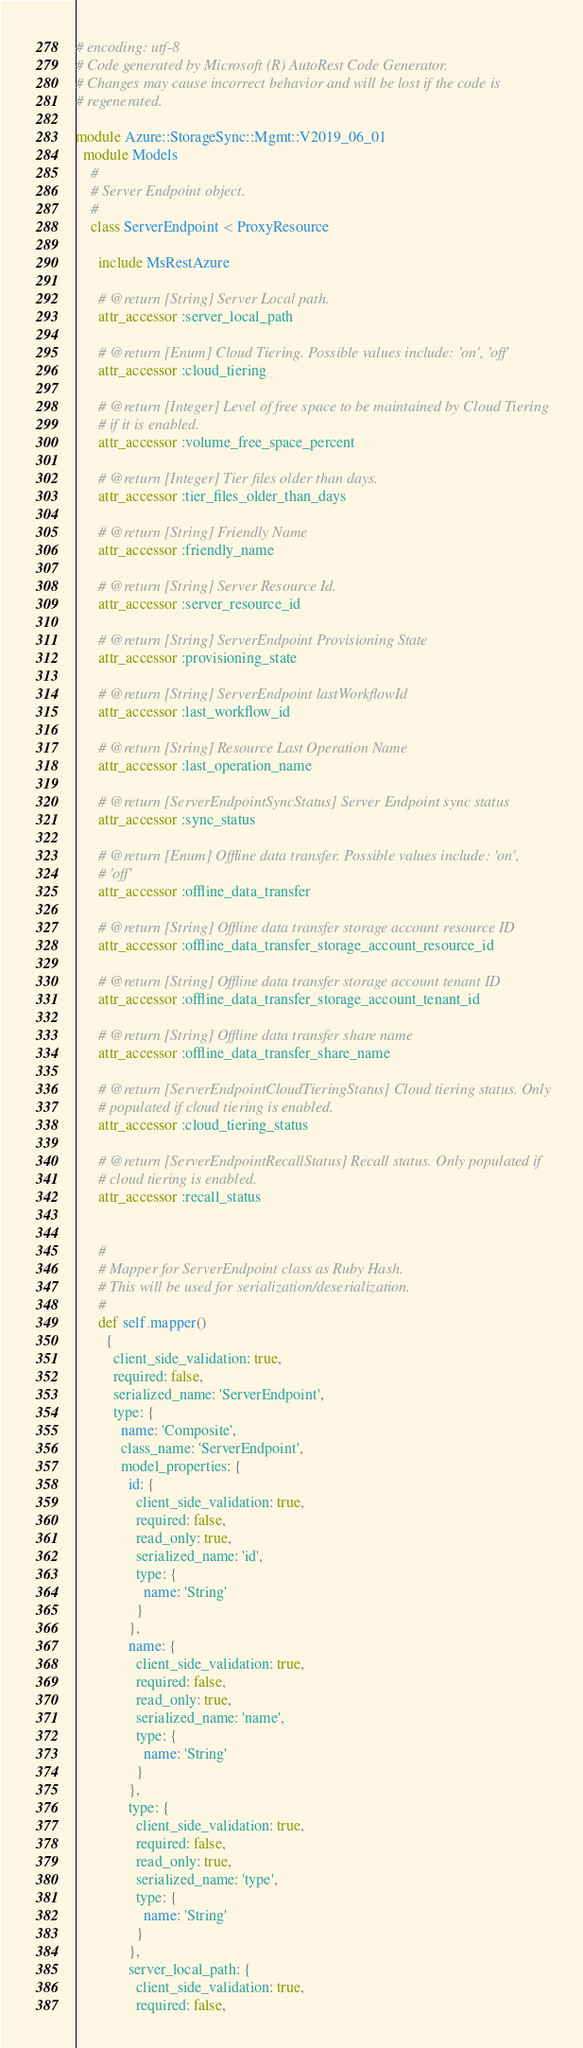Convert code to text. <code><loc_0><loc_0><loc_500><loc_500><_Ruby_># encoding: utf-8
# Code generated by Microsoft (R) AutoRest Code Generator.
# Changes may cause incorrect behavior and will be lost if the code is
# regenerated.

module Azure::StorageSync::Mgmt::V2019_06_01
  module Models
    #
    # Server Endpoint object.
    #
    class ServerEndpoint < ProxyResource

      include MsRestAzure

      # @return [String] Server Local path.
      attr_accessor :server_local_path

      # @return [Enum] Cloud Tiering. Possible values include: 'on', 'off'
      attr_accessor :cloud_tiering

      # @return [Integer] Level of free space to be maintained by Cloud Tiering
      # if it is enabled.
      attr_accessor :volume_free_space_percent

      # @return [Integer] Tier files older than days.
      attr_accessor :tier_files_older_than_days

      # @return [String] Friendly Name
      attr_accessor :friendly_name

      # @return [String] Server Resource Id.
      attr_accessor :server_resource_id

      # @return [String] ServerEndpoint Provisioning State
      attr_accessor :provisioning_state

      # @return [String] ServerEndpoint lastWorkflowId
      attr_accessor :last_workflow_id

      # @return [String] Resource Last Operation Name
      attr_accessor :last_operation_name

      # @return [ServerEndpointSyncStatus] Server Endpoint sync status
      attr_accessor :sync_status

      # @return [Enum] Offline data transfer. Possible values include: 'on',
      # 'off'
      attr_accessor :offline_data_transfer

      # @return [String] Offline data transfer storage account resource ID
      attr_accessor :offline_data_transfer_storage_account_resource_id

      # @return [String] Offline data transfer storage account tenant ID
      attr_accessor :offline_data_transfer_storage_account_tenant_id

      # @return [String] Offline data transfer share name
      attr_accessor :offline_data_transfer_share_name

      # @return [ServerEndpointCloudTieringStatus] Cloud tiering status. Only
      # populated if cloud tiering is enabled.
      attr_accessor :cloud_tiering_status

      # @return [ServerEndpointRecallStatus] Recall status. Only populated if
      # cloud tiering is enabled.
      attr_accessor :recall_status


      #
      # Mapper for ServerEndpoint class as Ruby Hash.
      # This will be used for serialization/deserialization.
      #
      def self.mapper()
        {
          client_side_validation: true,
          required: false,
          serialized_name: 'ServerEndpoint',
          type: {
            name: 'Composite',
            class_name: 'ServerEndpoint',
            model_properties: {
              id: {
                client_side_validation: true,
                required: false,
                read_only: true,
                serialized_name: 'id',
                type: {
                  name: 'String'
                }
              },
              name: {
                client_side_validation: true,
                required: false,
                read_only: true,
                serialized_name: 'name',
                type: {
                  name: 'String'
                }
              },
              type: {
                client_side_validation: true,
                required: false,
                read_only: true,
                serialized_name: 'type',
                type: {
                  name: 'String'
                }
              },
              server_local_path: {
                client_side_validation: true,
                required: false,</code> 